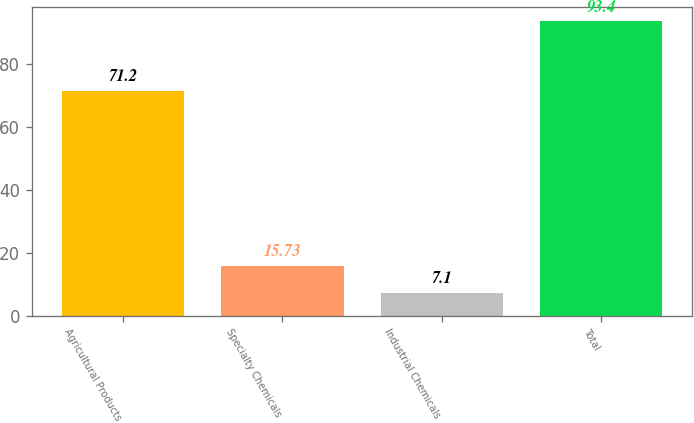<chart> <loc_0><loc_0><loc_500><loc_500><bar_chart><fcel>Agricultural Products<fcel>Specialty Chemicals<fcel>Industrial Chemicals<fcel>Total<nl><fcel>71.2<fcel>15.73<fcel>7.1<fcel>93.4<nl></chart> 